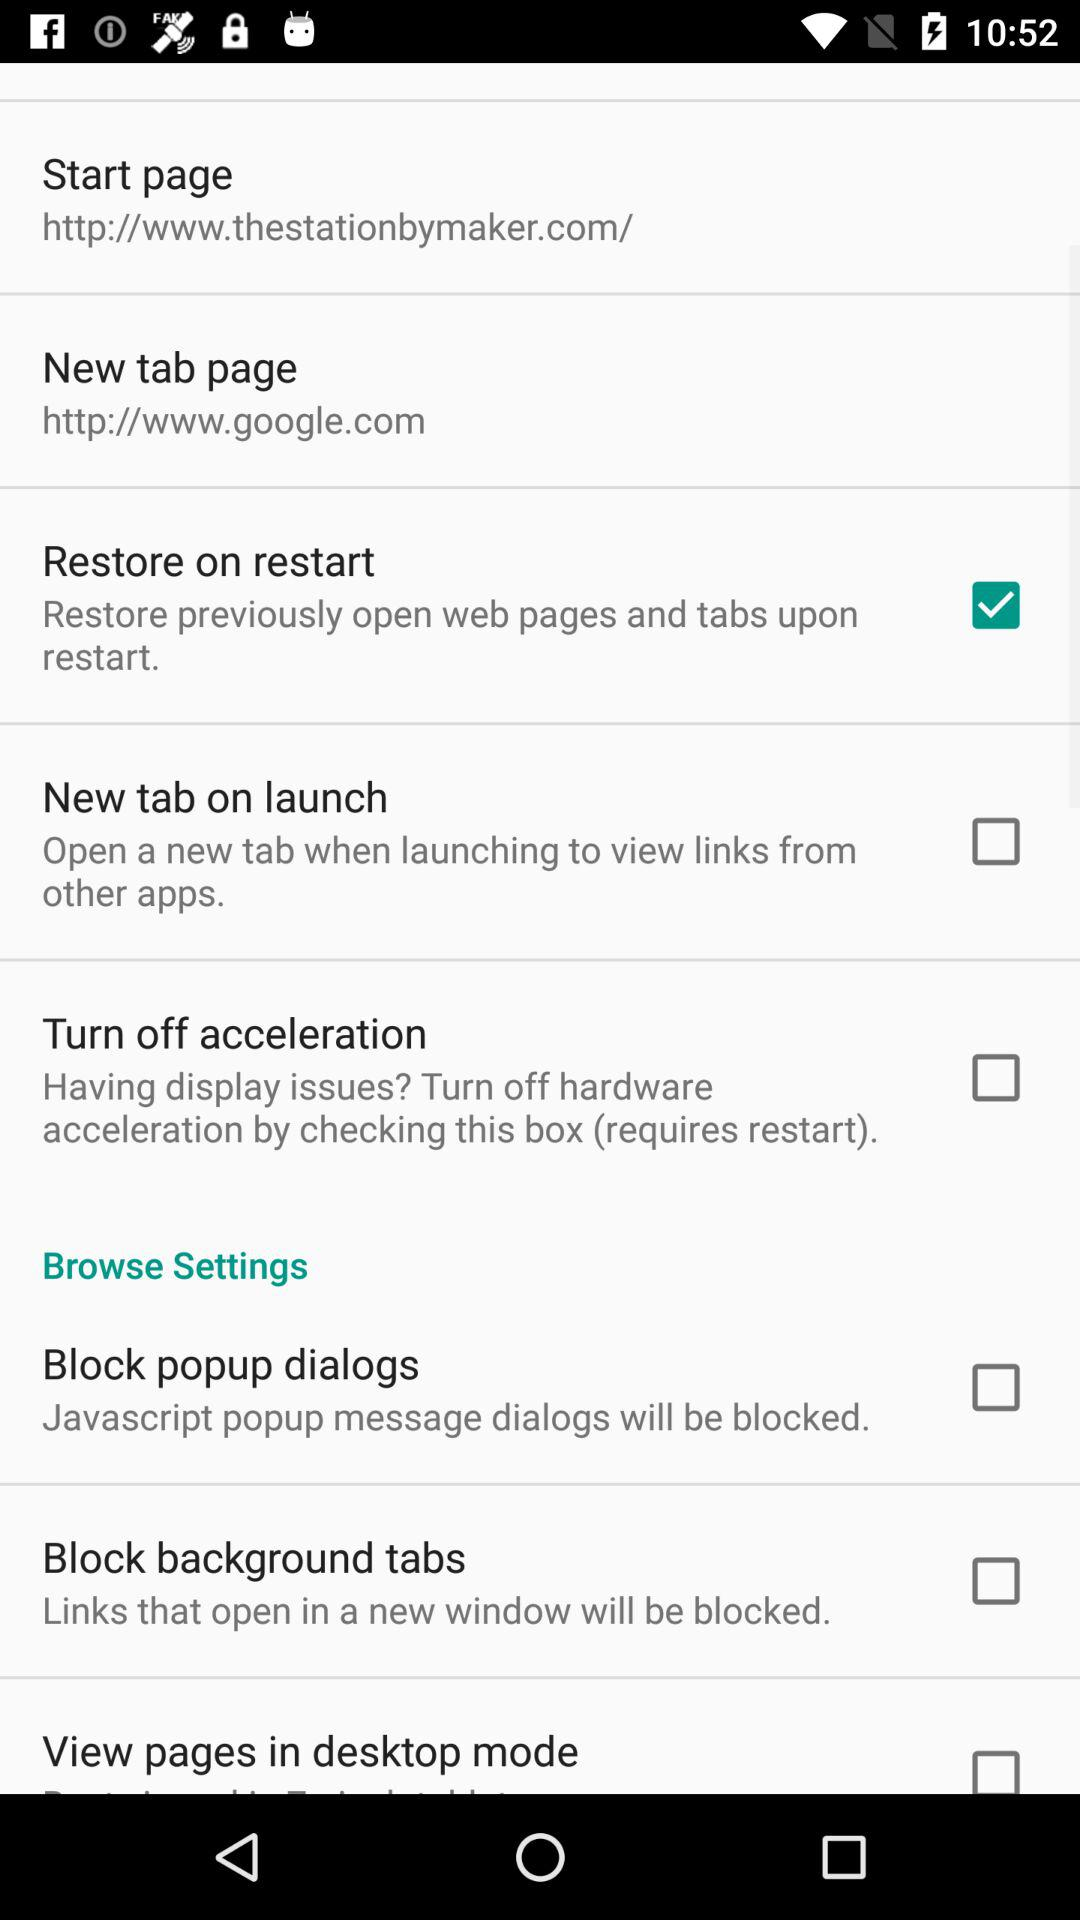What is the status of the new tab on launch? The status is off. 